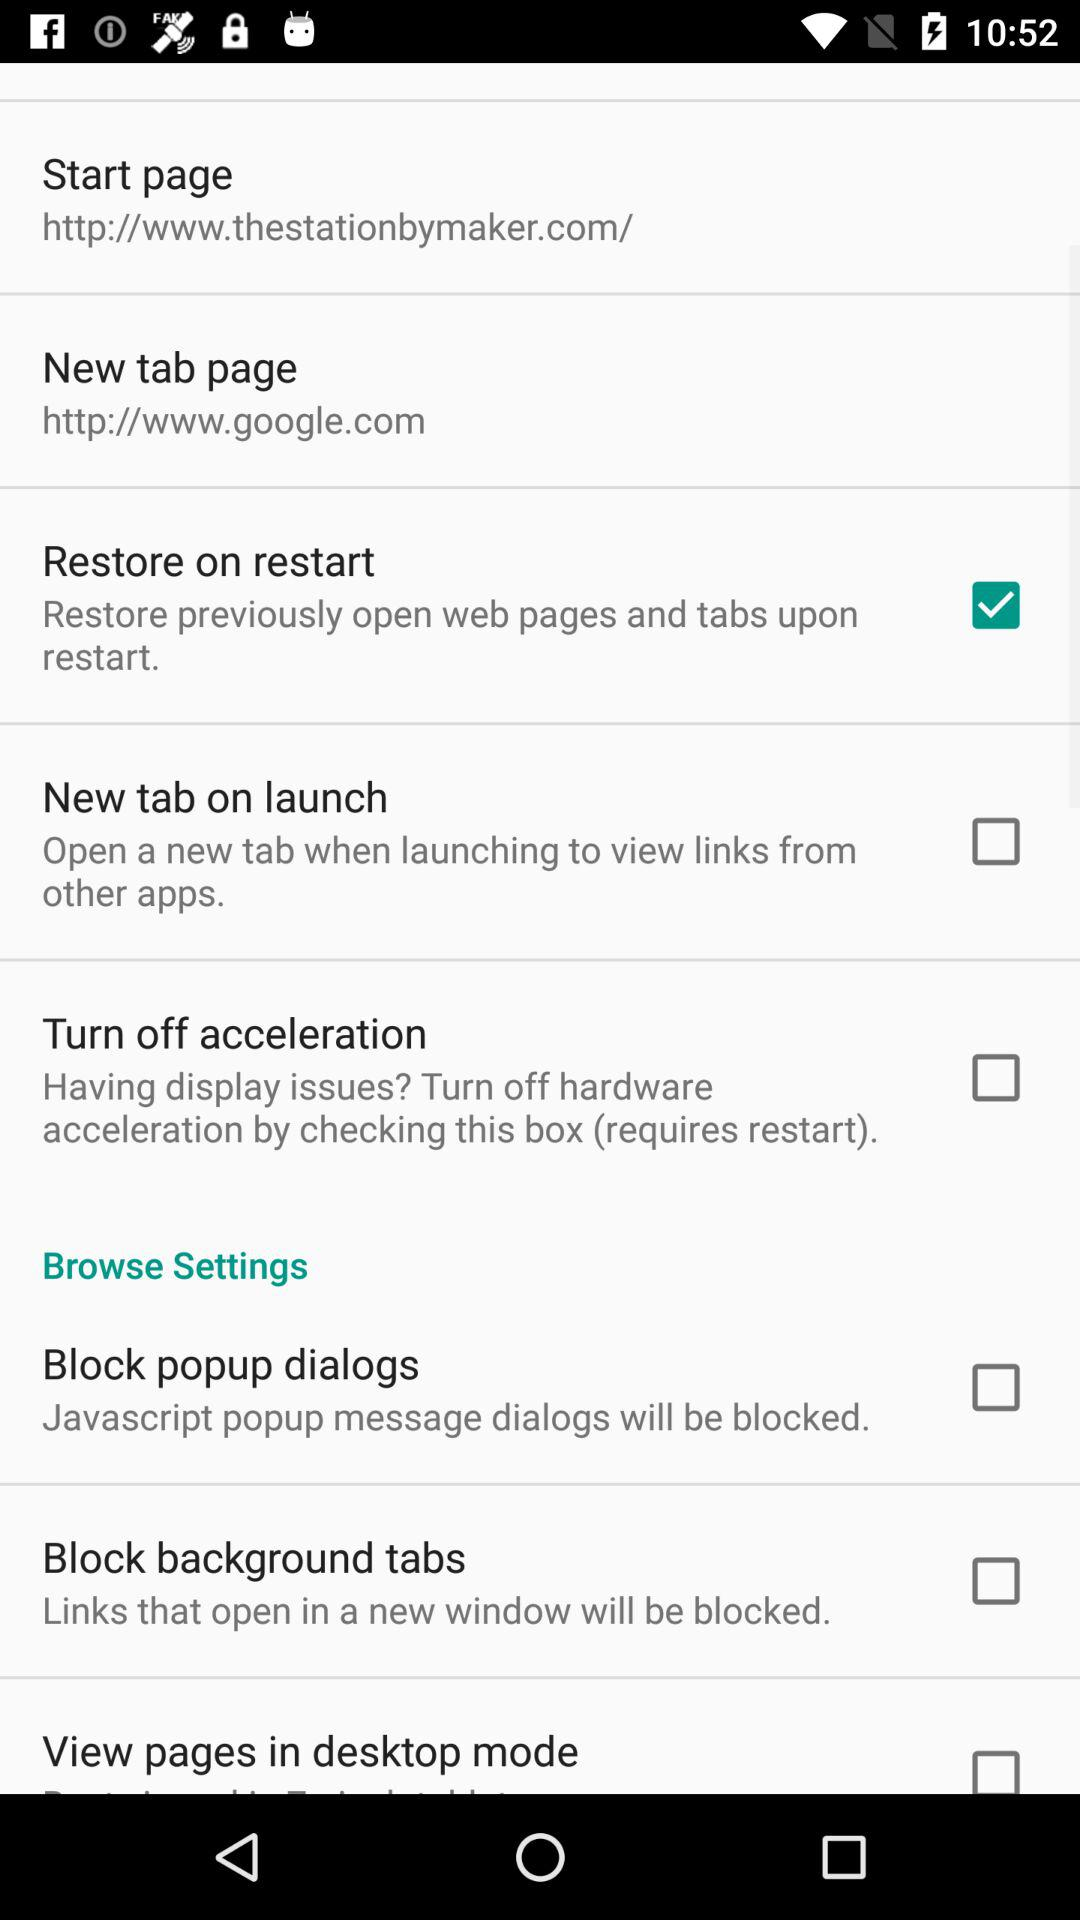What is the status of the new tab on launch? The status is off. 